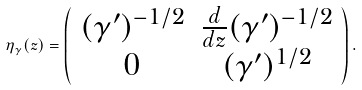<formula> <loc_0><loc_0><loc_500><loc_500>\eta _ { \gamma } ( z ) = \left ( \begin{array} { c c } { { ( \gamma ^ { \prime } ) ^ { - 1 / 2 } } } & { { { \frac { d } { d z } } ( \gamma ^ { \prime } ) ^ { - 1 / 2 } } } \\ { 0 } & { { ( \gamma ^ { \prime } ) ^ { 1 / 2 } } } \end{array} \right ) .</formula> 